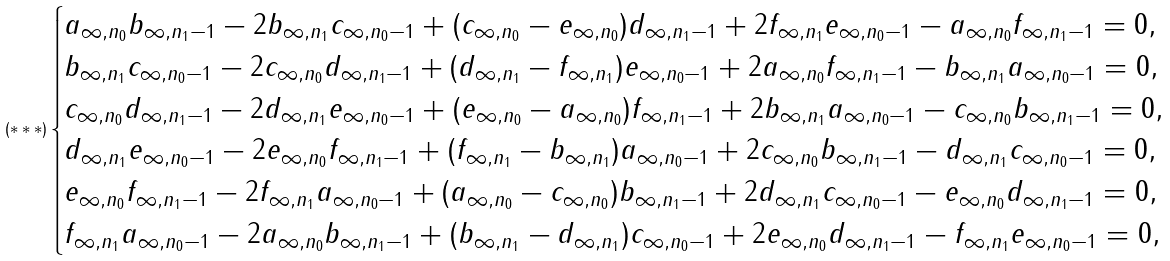Convert formula to latex. <formula><loc_0><loc_0><loc_500><loc_500>( * * * ) \begin{cases} a _ { \infty , n _ { 0 } } b _ { \infty , n _ { 1 } - 1 } - 2 b _ { \infty , n _ { 1 } } c _ { \infty , n _ { 0 } - 1 } + ( c _ { \infty , n _ { 0 } } - e _ { \infty , n _ { 0 } } ) d _ { \infty , n _ { 1 } - 1 } + 2 f _ { \infty , n _ { 1 } } e _ { \infty , n _ { 0 } - 1 } - a _ { \infty , n _ { 0 } } f _ { \infty , n _ { 1 } - 1 } = 0 , \\ b _ { \infty , n _ { 1 } } c _ { \infty , n _ { 0 } - 1 } - 2 c _ { \infty , n _ { 0 } } d _ { \infty , n _ { 1 } - 1 } + ( d _ { \infty , n _ { 1 } } - f _ { \infty , n _ { 1 } } ) e _ { \infty , n _ { 0 } - 1 } + 2 a _ { \infty , n _ { 0 } } f _ { \infty , n _ { 1 } - 1 } - b _ { \infty , n _ { 1 } } a _ { \infty , n _ { 0 } - 1 } = 0 , \\ c _ { \infty , n _ { 0 } } d _ { \infty , n _ { 1 } - 1 } - 2 d _ { \infty , n _ { 1 } } e _ { \infty , n _ { 0 } - 1 } + ( e _ { \infty , n _ { 0 } } - a _ { \infty , n _ { 0 } } ) f _ { \infty , n _ { 1 } - 1 } + 2 b _ { \infty , n _ { 1 } } a _ { \infty , n _ { 0 } - 1 } - c _ { \infty , n _ { 0 } } b _ { \infty , n _ { 1 } - 1 } = 0 , \\ d _ { \infty , n _ { 1 } } e _ { \infty , n _ { 0 } - 1 } - 2 e _ { \infty , n _ { 0 } } f _ { \infty , n _ { 1 } - 1 } + ( f _ { \infty , n _ { 1 } } - b _ { \infty , n _ { 1 } } ) a _ { \infty , n _ { 0 } - 1 } + 2 c _ { \infty , n _ { 0 } } b _ { \infty , n _ { 1 } - 1 } - d _ { \infty , n _ { 1 } } c _ { \infty , n _ { 0 } - 1 } = 0 , \\ e _ { \infty , n _ { 0 } } f _ { \infty , n _ { 1 } - 1 } - 2 f _ { \infty , n _ { 1 } } a _ { \infty , n _ { 0 } - 1 } + ( a _ { \infty , n _ { 0 } } - c _ { \infty , n _ { 0 } } ) b _ { \infty , n _ { 1 } - 1 } + 2 d _ { \infty , n _ { 1 } } c _ { \infty , n _ { 0 } - 1 } - e _ { \infty , n _ { 0 } } d _ { \infty , n _ { 1 } - 1 } = 0 , \\ f _ { \infty , n _ { 1 } } a _ { \infty , n _ { 0 } - 1 } - 2 a _ { \infty , n _ { 0 } } b _ { \infty , n _ { 1 } - 1 } + ( b _ { \infty , n _ { 1 } } - d _ { \infty , n _ { 1 } } ) c _ { \infty , n _ { 0 } - 1 } + 2 e _ { \infty , n _ { 0 } } d _ { \infty , n _ { 1 } - 1 } - f _ { \infty , n _ { 1 } } e _ { \infty , n _ { 0 } - 1 } = 0 , \\ \end{cases}</formula> 